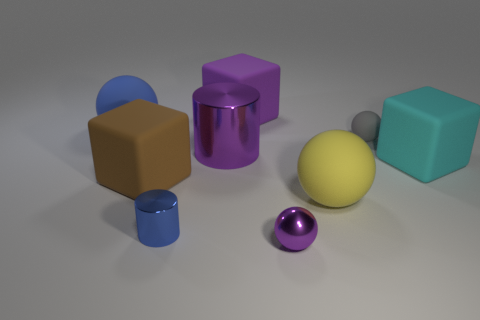Add 1 large cylinders. How many objects exist? 10 Subtract all balls. How many objects are left? 5 Subtract 1 brown cubes. How many objects are left? 8 Subtract all tiny purple metallic things. Subtract all purple rubber cubes. How many objects are left? 7 Add 1 small purple things. How many small purple things are left? 2 Add 3 gray objects. How many gray objects exist? 4 